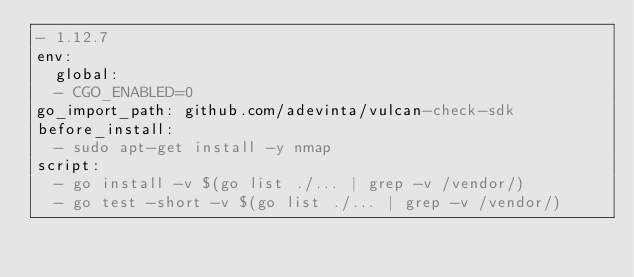Convert code to text. <code><loc_0><loc_0><loc_500><loc_500><_YAML_>- 1.12.7
env:
  global:
  - CGO_ENABLED=0
go_import_path: github.com/adevinta/vulcan-check-sdk
before_install:
  - sudo apt-get install -y nmap
script:
  - go install -v $(go list ./... | grep -v /vendor/)
  - go test -short -v $(go list ./... | grep -v /vendor/)
</code> 